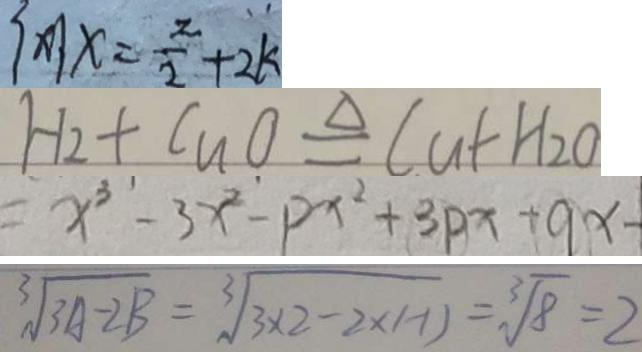<formula> <loc_0><loc_0><loc_500><loc_500>\{ x \vert x = \frac { z } { 2 } + 2 k 
 H _ { 2 } + C u O \xlongequal { \Delta } C u + H _ { 2 } O 
 = x ^ { 3 } - 3 x ^ { 2 } - P x ^ { 2 } + 3 p x + 9 x - 
 \sqrt [ 3 ] { 3 A - 2 B } = \sqrt [ 3 ] { 3 \times 2 - 2 \times ( - 1 ) } = \sqrt [ 3 ] { 8 } = 2</formula> 